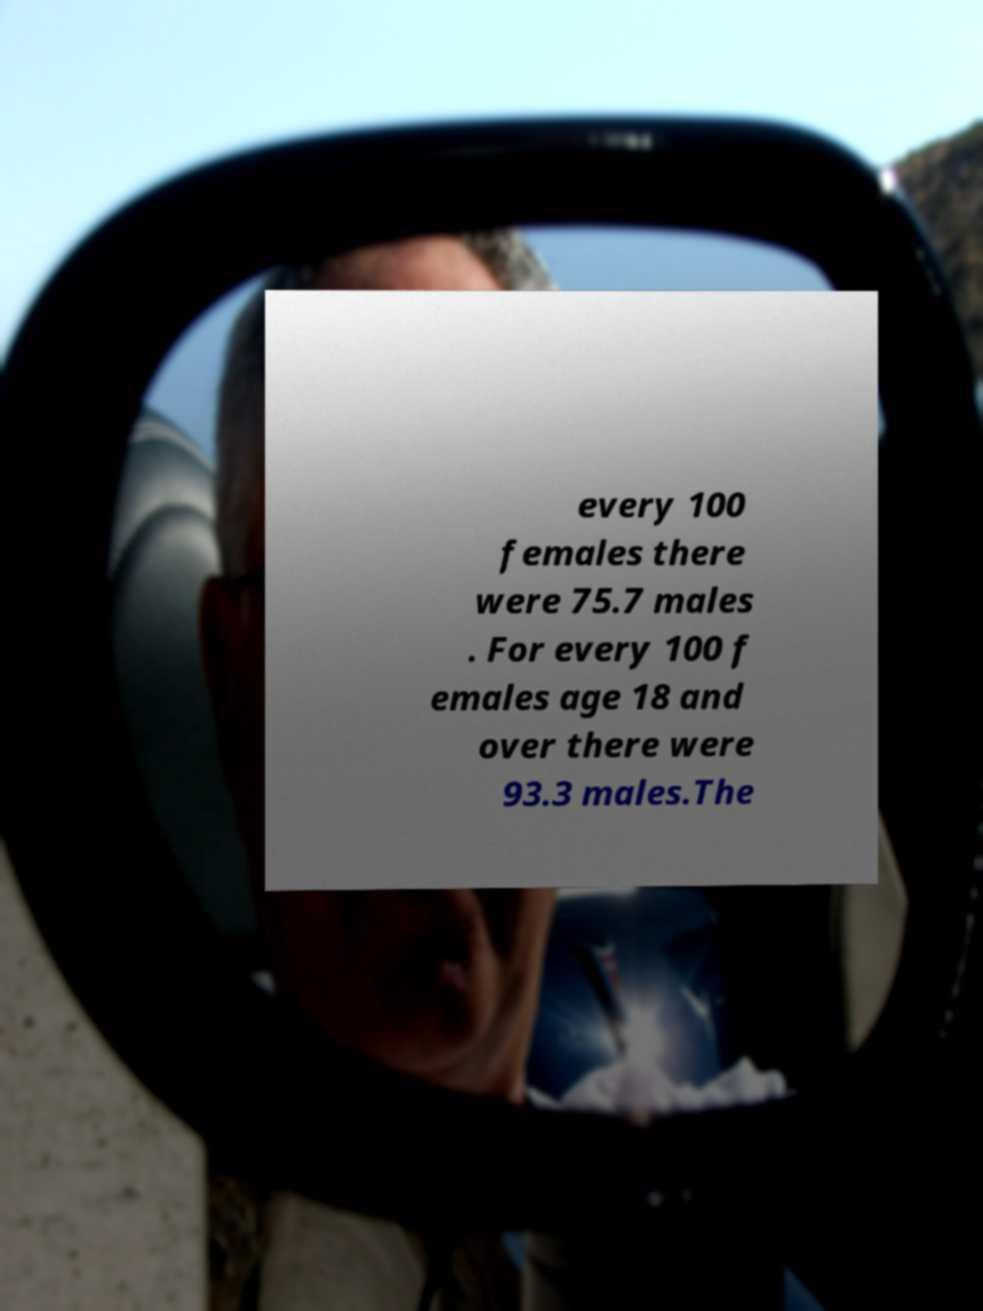Could you assist in decoding the text presented in this image and type it out clearly? every 100 females there were 75.7 males . For every 100 f emales age 18 and over there were 93.3 males.The 